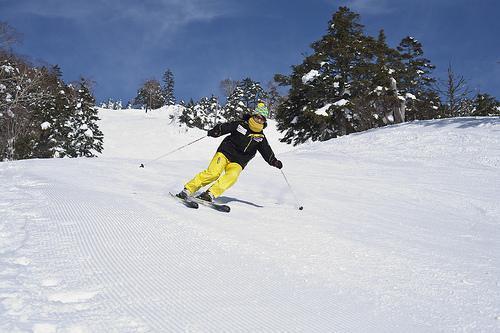How many people are skiing?
Give a very brief answer. 1. How many poles does the skier have?
Give a very brief answer. 2. 